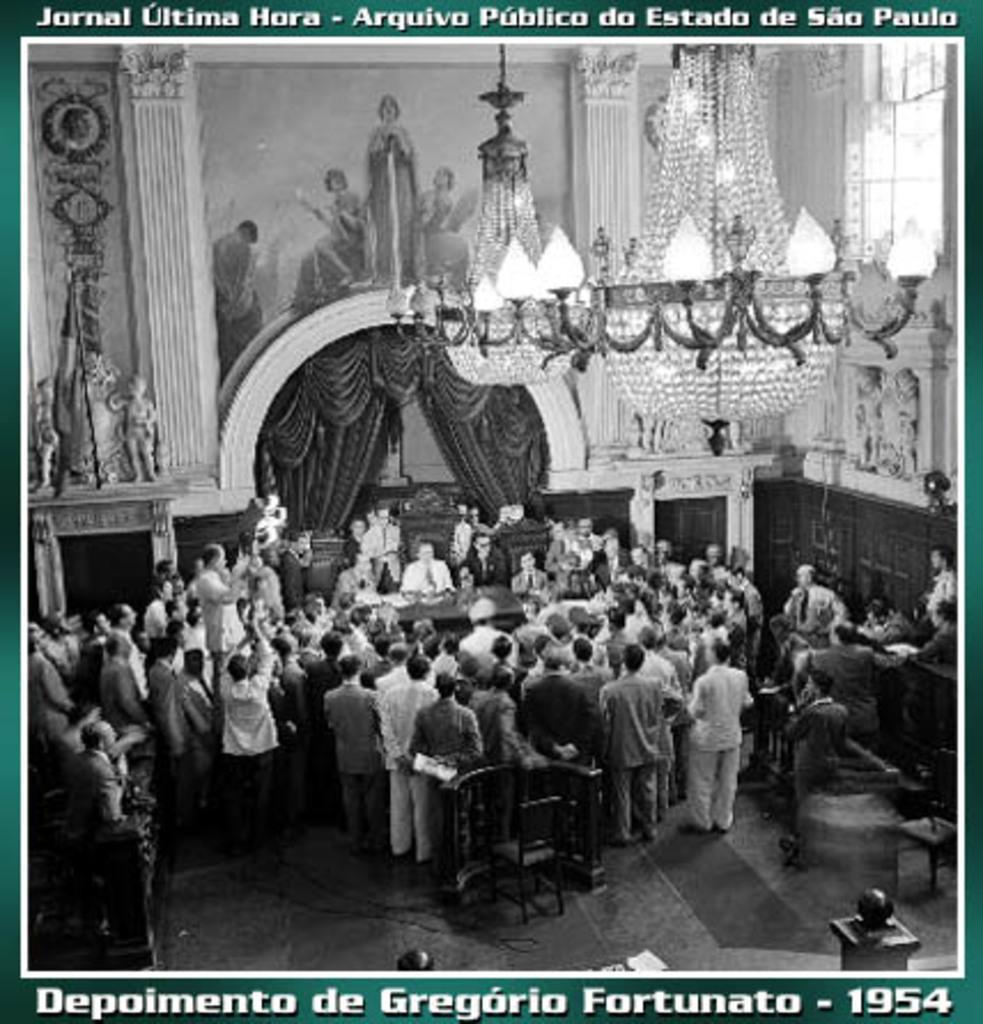Can you describe this image briefly? This is an image of the photograph where we can see so many people standing inside the room, also there is a chandelier hanging from the ceiling. 